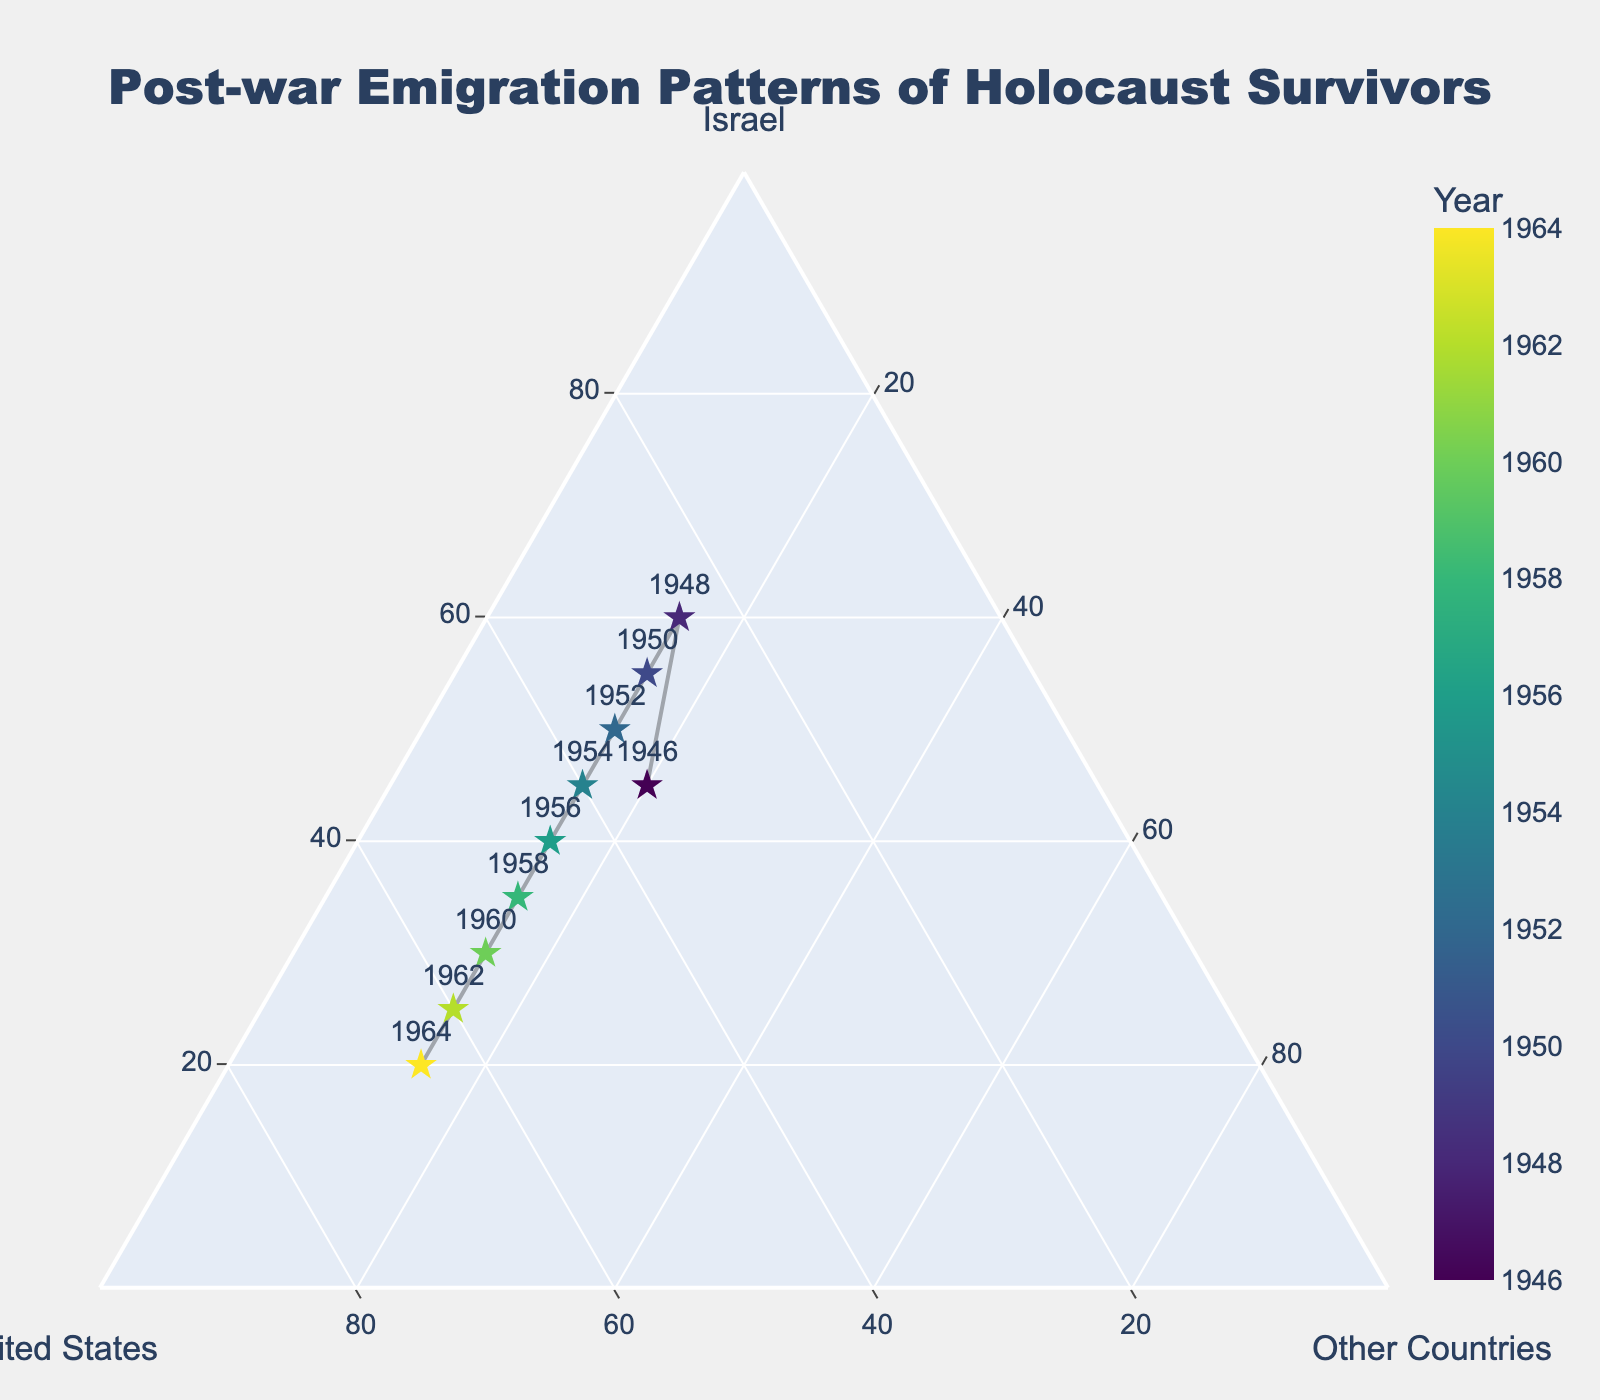What is the title of the figure? The title of the figure is typically displayed at the top center. In this case, it should clearly state the overall topic of the plot.
Answer: Post-war Emigration Patterns of Holocaust Survivors How many countries does the ternary plot focus on? A ternary plot shows proportions of three variables that sum up to a constant. This plot focuses on emigration to three countries.
Answer: Three (Israel, United States, Other Countries) Which year shows the highest proportion of emigration to Israel? The highest proportion of emigration to Israel can be determined by observing which point is closest to the Israel axis. In this case, the year 1948 shows the highest proportion.
Answer: 1948 How does the proportion of emigration to the United States change over the years? To answer this, observe the points' positions and the color gradient. Over time, the points move closer to the United States axis, indicating an increasing proportion of emigration to the U.S.
Answer: It increases In what year does the proportion of emigration to other countries remain constant, and what is its value? Look for the vertical alignment of points relative to the 'Other Countries' axis. It remains constant in all years, with a value of 15%.
Answer: All years, 15% By how much does the proportion of emigration to the United States increase from 1946 to 1964? Calculate the difference between the proportions in 1964 and 1946. In 1964, the proportion is 65%, and in 1946, it's 35%.
Answer: 30% Which country sees a steady decline in the proportion of emigration over the years? Observe the trend of points gradually moving away from one axis. In this case, the proportion of emigration to Israel steadily declines.
Answer: Israel Can you identify a year where the proportion of emigration to Israel exceeded 50%? Look for a point that is predominantly positioned towards the Israel axis. The year 1948 shows a value greater than 50%.
Answer: 1948 What is the overall trend observed in the emigration patterns over the years? The overall pattern can be observed by analyzing the shifts in data points. Emigration to Israel decreases, the United States increases, and other countries remain constant at 15%.
Answer: Decrease in Israel, increase in the United States, constant in Other Countries 